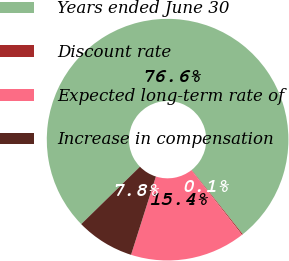<chart> <loc_0><loc_0><loc_500><loc_500><pie_chart><fcel>Years ended June 30<fcel>Discount rate<fcel>Expected long-term rate of<fcel>Increase in compensation<nl><fcel>76.63%<fcel>0.14%<fcel>15.44%<fcel>7.79%<nl></chart> 